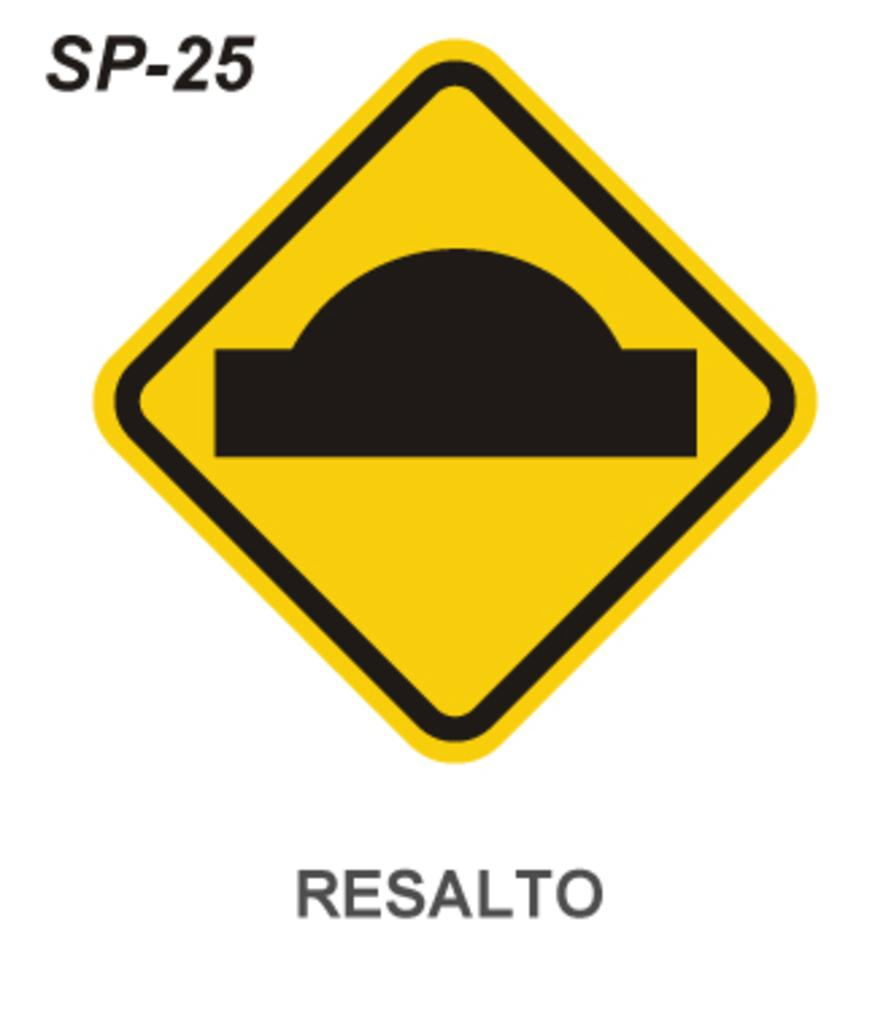<image>
Summarize the visual content of the image. A triangle shaped, yellow street sign with a rectangle and a half circle on top of the rectangle is above the word RESALTO. 